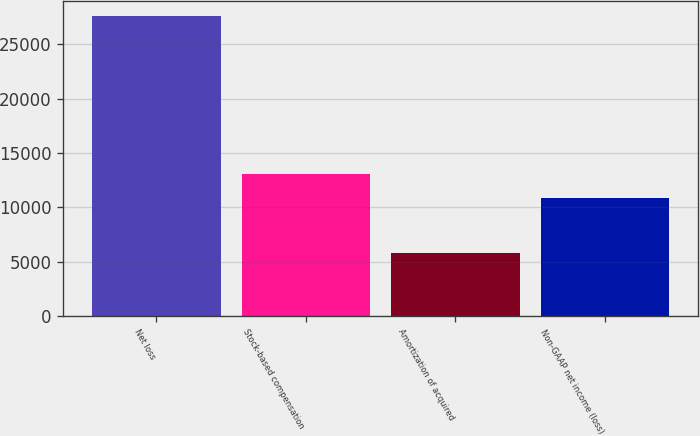Convert chart. <chart><loc_0><loc_0><loc_500><loc_500><bar_chart><fcel>Net loss<fcel>Stock-based compensation<fcel>Amortization of acquired<fcel>Non-GAAP net income (loss)<nl><fcel>27583<fcel>13039.3<fcel>5820<fcel>10863<nl></chart> 